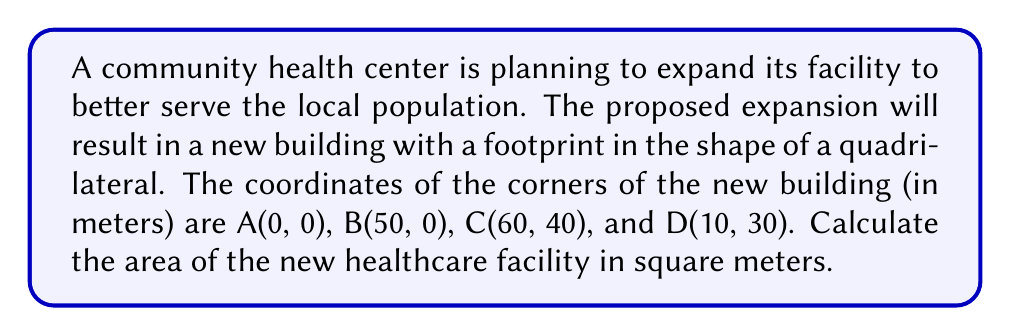What is the answer to this math problem? To calculate the area of the quadrilateral healthcare facility, we can use the shoelace formula (also known as the surveyor's formula). This method is particularly useful for calculating the area of a polygon given the coordinates of its vertices.

The shoelace formula for a quadrilateral ABCD with coordinates $(x_1, y_1)$, $(x_2, y_2)$, $(x_3, y_3)$, and $(x_4, y_4)$ is:

$$\text{Area} = \frac{1}{2}|(x_1y_2 + x_2y_3 + x_3y_4 + x_4y_1) - (y_1x_2 + y_2x_3 + y_3x_4 + y_4x_1)|$$

Let's substitute the given coordinates:
A(0, 0), B(50, 0), C(60, 40), D(10, 30)

$$(x_1, y_1) = (0, 0)$$
$$(x_2, y_2) = (50, 0)$$
$$(x_3, y_3) = (60, 40)$$
$$(x_4, y_4) = (10, 30)$$

Now, let's calculate each term:

$$\begin{align*}
x_1y_2 &= 0 \cdot 0 = 0 \\
x_2y_3 &= 50 \cdot 40 = 2000 \\
x_3y_4 &= 60 \cdot 30 = 1800 \\
x_4y_1 &= 10 \cdot 0 = 0 \\
y_1x_2 &= 0 \cdot 50 = 0 \\
y_2x_3 &= 0 \cdot 60 = 0 \\
y_3x_4 &= 40 \cdot 10 = 400 \\
y_4x_1 &= 30 \cdot 0 = 0
\end{align*}$$

Substituting these values into the formula:

$$\begin{align*}
\text{Area} &= \frac{1}{2}|(0 + 2000 + 1800 + 0) - (0 + 0 + 400 + 0)| \\
&= \frac{1}{2}|3800 - 400| \\
&= \frac{1}{2} \cdot 3400 \\
&= 1700
\end{align*}$$

Therefore, the area of the new healthcare facility is 1700 square meters.
Answer: 1700 square meters 